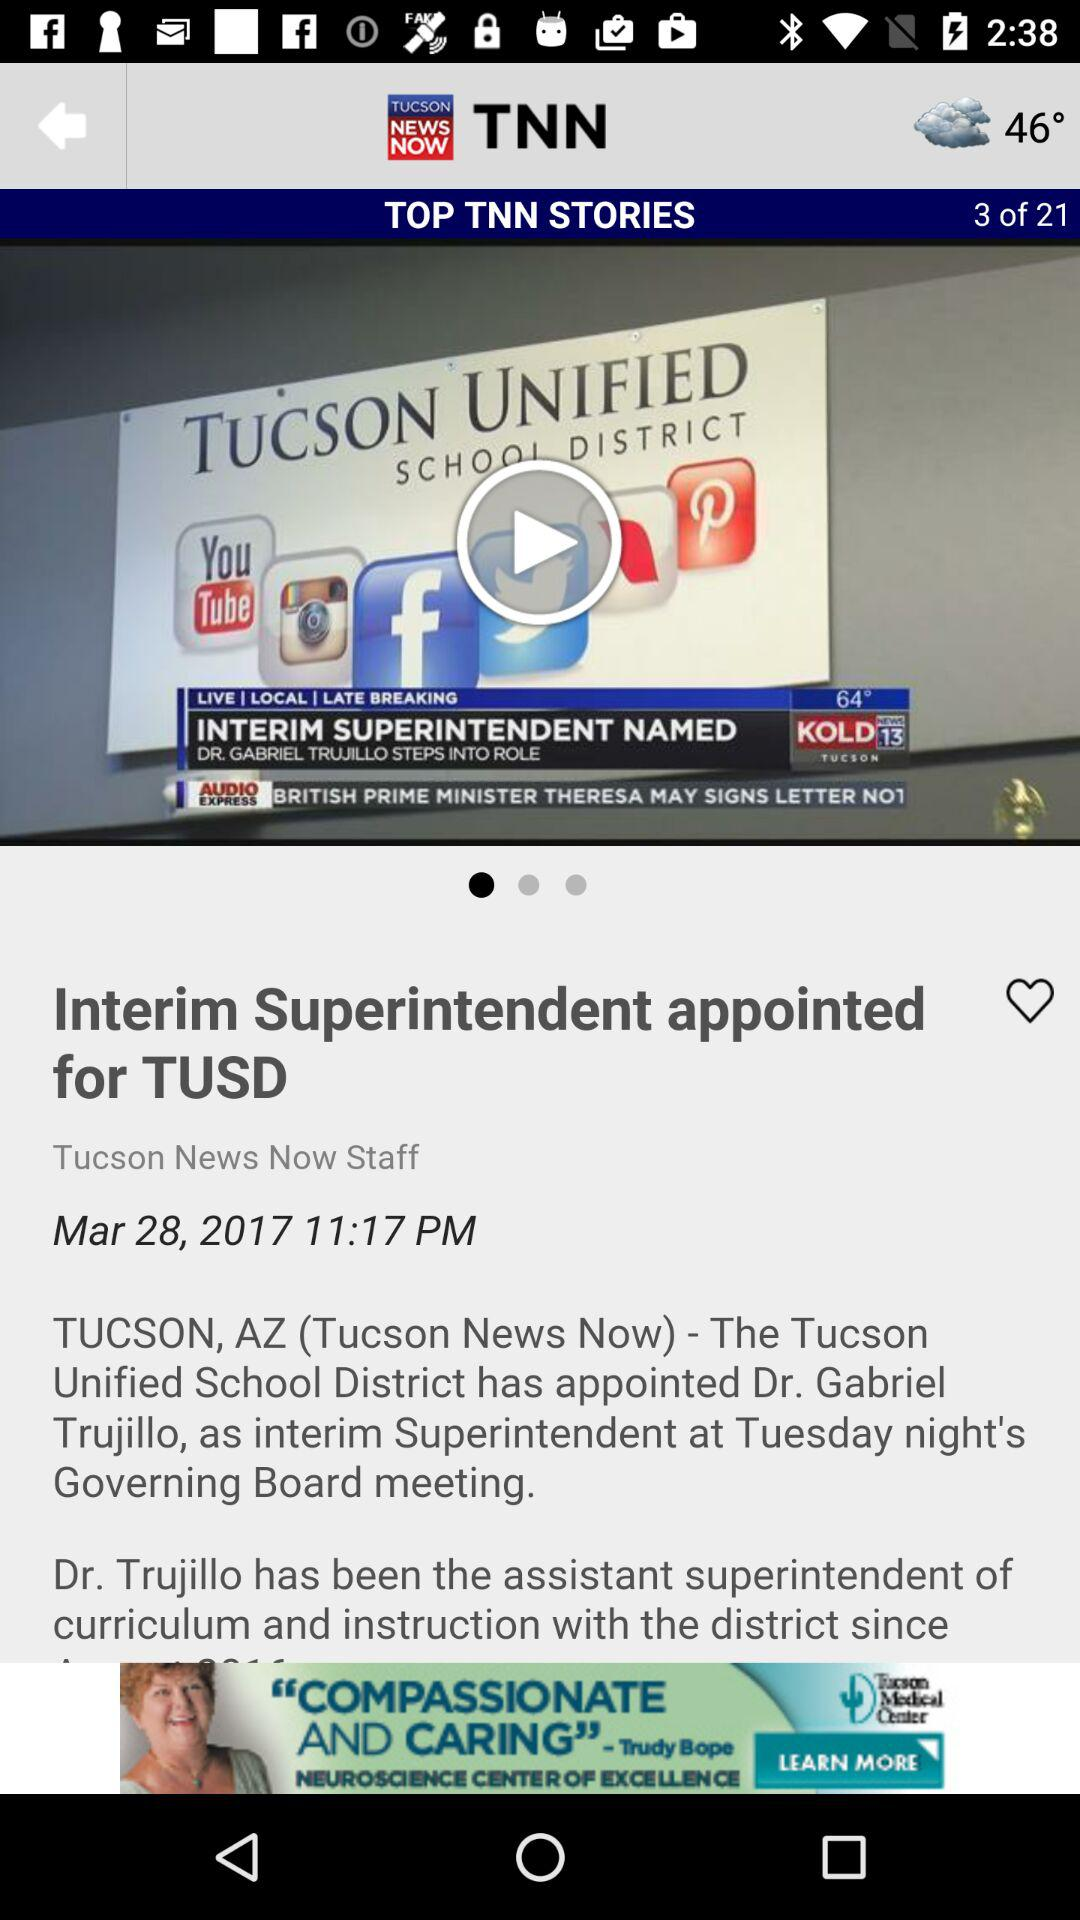What is the temperature? The temperature is 46°. 